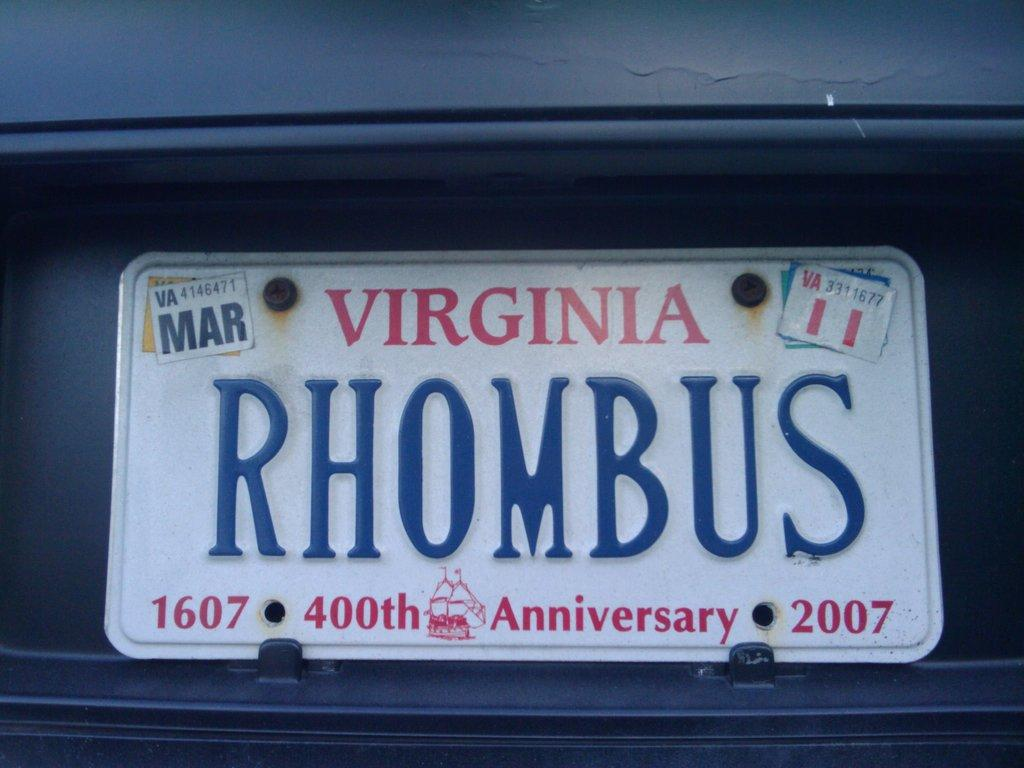<image>
Describe the image concisely. A 2007 Virginia Vanity car plate says RHOMBUS 